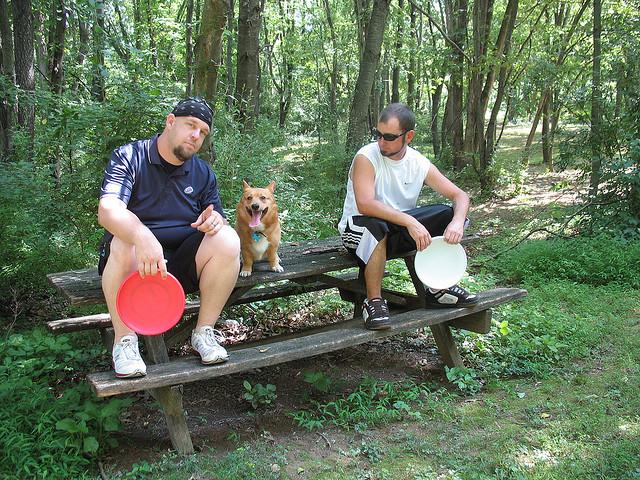Are both frisbees the same color?
Concise answer only. No. Is there people on the bench?
Quick response, please. Yes. Where is the man pointing?
Concise answer only. At camera. 